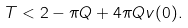Convert formula to latex. <formula><loc_0><loc_0><loc_500><loc_500>T < 2 - \pi Q + 4 \pi Q v ( 0 ) .</formula> 